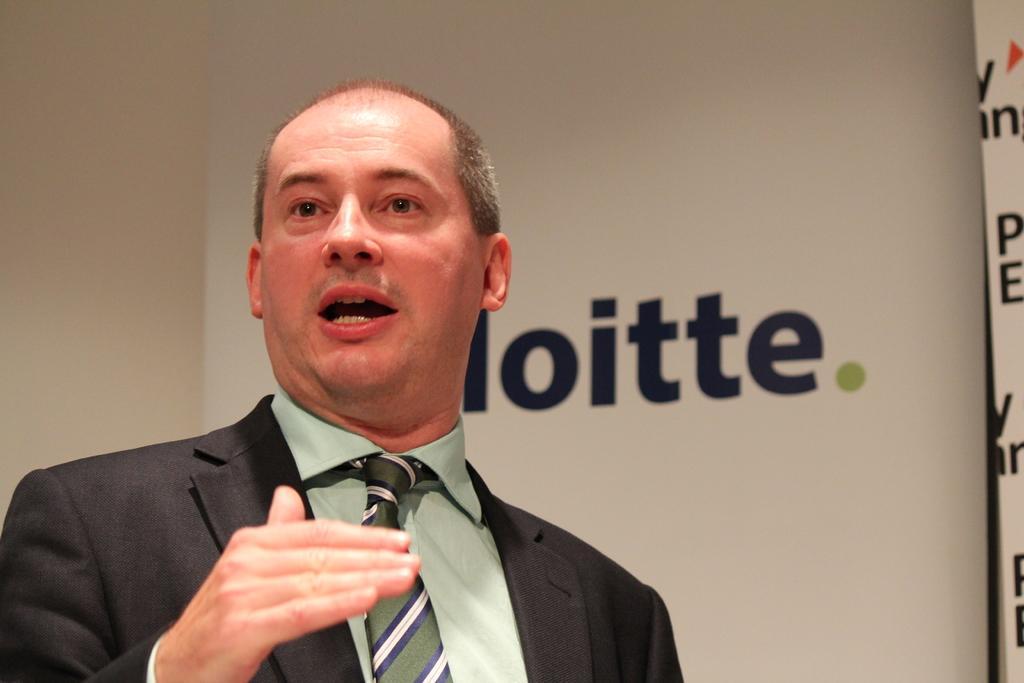Could you give a brief overview of what you see in this image? In this picture I can see there is a man standing and he is wearing a suit, tie and a shirt. There is a logo on the banner behind him and the man is speaking. 